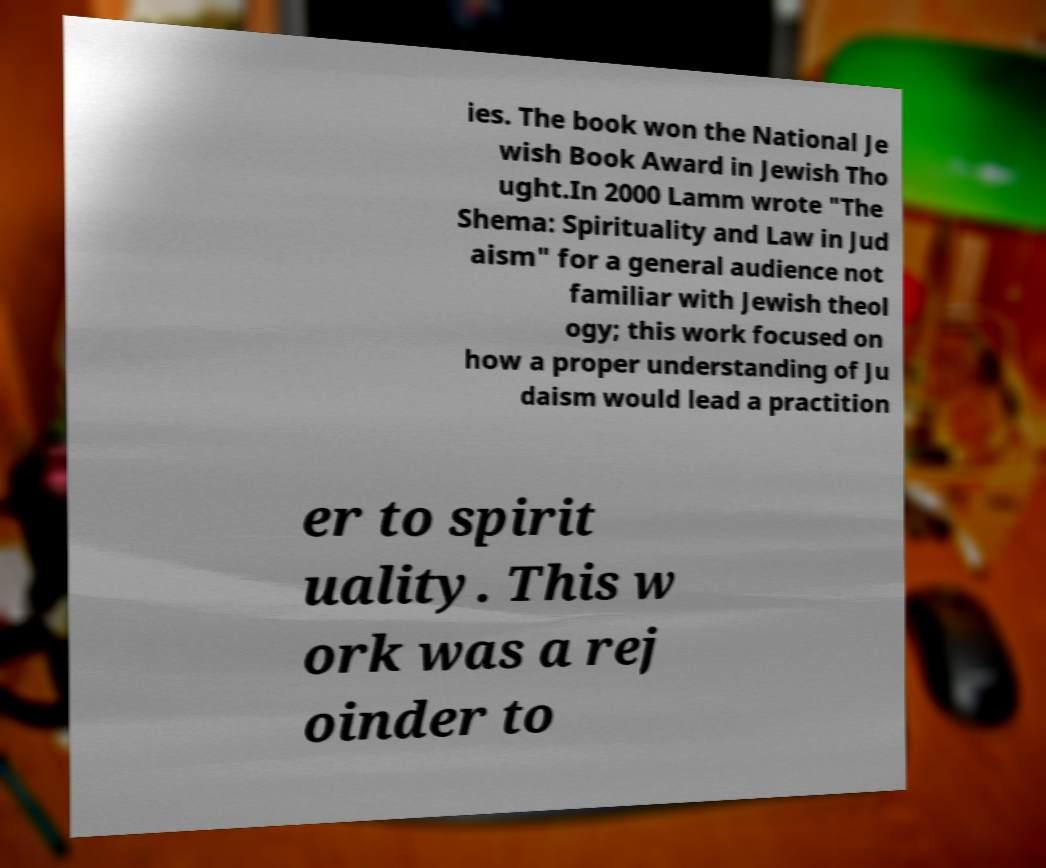Please identify and transcribe the text found in this image. ies. The book won the National Je wish Book Award in Jewish Tho ught.In 2000 Lamm wrote "The Shema: Spirituality and Law in Jud aism" for a general audience not familiar with Jewish theol ogy; this work focused on how a proper understanding of Ju daism would lead a practition er to spirit uality. This w ork was a rej oinder to 